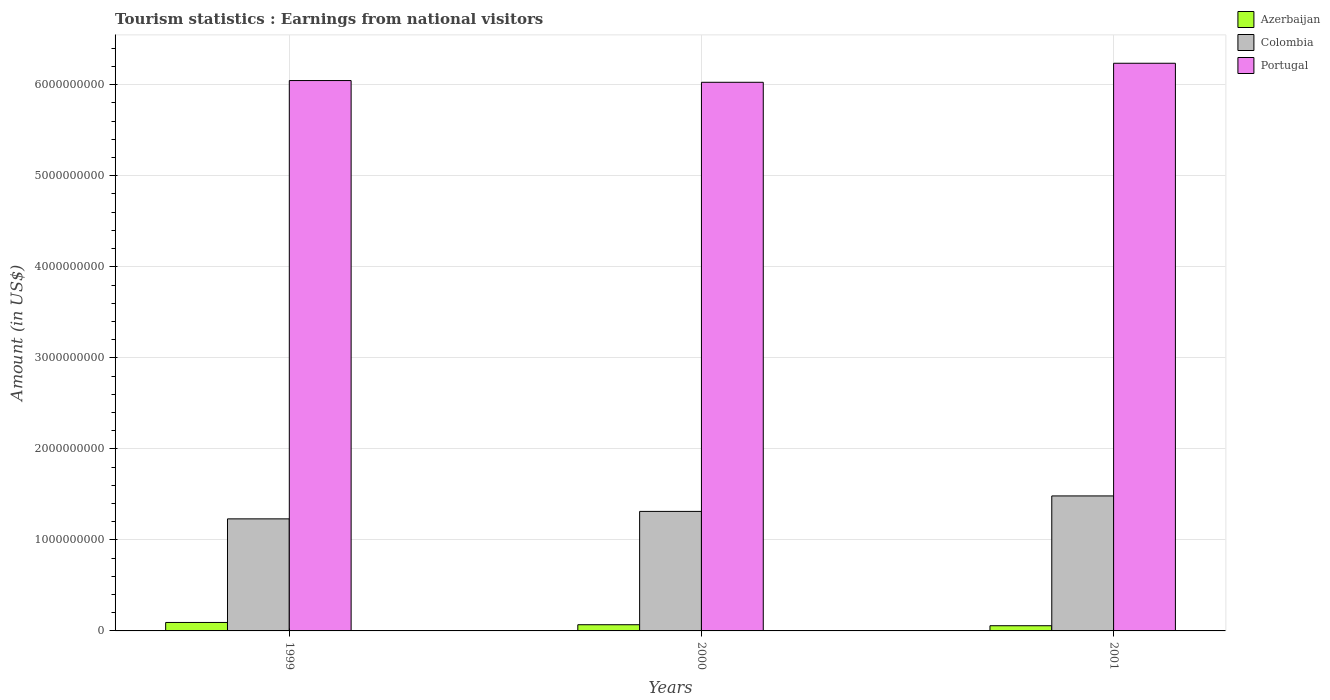How many different coloured bars are there?
Your answer should be compact. 3. How many groups of bars are there?
Ensure brevity in your answer.  3. How many bars are there on the 1st tick from the left?
Ensure brevity in your answer.  3. How many bars are there on the 2nd tick from the right?
Provide a short and direct response. 3. What is the earnings from national visitors in Azerbaijan in 1999?
Your answer should be very brief. 9.30e+07. Across all years, what is the maximum earnings from national visitors in Portugal?
Your answer should be very brief. 6.24e+09. Across all years, what is the minimum earnings from national visitors in Portugal?
Keep it short and to the point. 6.03e+09. In which year was the earnings from national visitors in Azerbaijan minimum?
Your answer should be compact. 2001. What is the total earnings from national visitors in Portugal in the graph?
Your response must be concise. 1.83e+1. What is the difference between the earnings from national visitors in Portugal in 1999 and that in 2001?
Offer a very short reply. -1.90e+08. What is the difference between the earnings from national visitors in Portugal in 2000 and the earnings from national visitors in Azerbaijan in 1999?
Give a very brief answer. 5.93e+09. What is the average earnings from national visitors in Colombia per year?
Give a very brief answer. 1.34e+09. In the year 2000, what is the difference between the earnings from national visitors in Colombia and earnings from national visitors in Portugal?
Offer a terse response. -4.71e+09. What is the ratio of the earnings from national visitors in Colombia in 1999 to that in 2001?
Your answer should be compact. 0.83. Is the earnings from national visitors in Portugal in 1999 less than that in 2000?
Keep it short and to the point. No. What is the difference between the highest and the second highest earnings from national visitors in Colombia?
Provide a short and direct response. 1.70e+08. What is the difference between the highest and the lowest earnings from national visitors in Portugal?
Provide a short and direct response. 2.09e+08. In how many years, is the earnings from national visitors in Portugal greater than the average earnings from national visitors in Portugal taken over all years?
Provide a short and direct response. 1. Is the sum of the earnings from national visitors in Colombia in 1999 and 2001 greater than the maximum earnings from national visitors in Azerbaijan across all years?
Provide a short and direct response. Yes. What does the 1st bar from the left in 2000 represents?
Your answer should be compact. Azerbaijan. What does the 3rd bar from the right in 2001 represents?
Ensure brevity in your answer.  Azerbaijan. Is it the case that in every year, the sum of the earnings from national visitors in Portugal and earnings from national visitors in Colombia is greater than the earnings from national visitors in Azerbaijan?
Offer a very short reply. Yes. How many bars are there?
Make the answer very short. 9. Are all the bars in the graph horizontal?
Your response must be concise. No. How many years are there in the graph?
Your answer should be very brief. 3. What is the difference between two consecutive major ticks on the Y-axis?
Your answer should be very brief. 1.00e+09. Where does the legend appear in the graph?
Provide a succinct answer. Top right. What is the title of the graph?
Ensure brevity in your answer.  Tourism statistics : Earnings from national visitors. What is the label or title of the X-axis?
Make the answer very short. Years. What is the Amount (in US$) of Azerbaijan in 1999?
Provide a short and direct response. 9.30e+07. What is the Amount (in US$) of Colombia in 1999?
Offer a terse response. 1.23e+09. What is the Amount (in US$) of Portugal in 1999?
Ensure brevity in your answer.  6.05e+09. What is the Amount (in US$) in Azerbaijan in 2000?
Offer a terse response. 6.80e+07. What is the Amount (in US$) in Colombia in 2000?
Offer a very short reply. 1.31e+09. What is the Amount (in US$) in Portugal in 2000?
Provide a short and direct response. 6.03e+09. What is the Amount (in US$) of Azerbaijan in 2001?
Keep it short and to the point. 5.70e+07. What is the Amount (in US$) of Colombia in 2001?
Ensure brevity in your answer.  1.48e+09. What is the Amount (in US$) of Portugal in 2001?
Keep it short and to the point. 6.24e+09. Across all years, what is the maximum Amount (in US$) of Azerbaijan?
Offer a very short reply. 9.30e+07. Across all years, what is the maximum Amount (in US$) of Colombia?
Offer a terse response. 1.48e+09. Across all years, what is the maximum Amount (in US$) of Portugal?
Offer a terse response. 6.24e+09. Across all years, what is the minimum Amount (in US$) of Azerbaijan?
Make the answer very short. 5.70e+07. Across all years, what is the minimum Amount (in US$) in Colombia?
Your answer should be compact. 1.23e+09. Across all years, what is the minimum Amount (in US$) in Portugal?
Provide a succinct answer. 6.03e+09. What is the total Amount (in US$) in Azerbaijan in the graph?
Your answer should be compact. 2.18e+08. What is the total Amount (in US$) of Colombia in the graph?
Keep it short and to the point. 4.03e+09. What is the total Amount (in US$) of Portugal in the graph?
Make the answer very short. 1.83e+1. What is the difference between the Amount (in US$) of Azerbaijan in 1999 and that in 2000?
Provide a succinct answer. 2.50e+07. What is the difference between the Amount (in US$) in Colombia in 1999 and that in 2000?
Provide a succinct answer. -8.20e+07. What is the difference between the Amount (in US$) in Portugal in 1999 and that in 2000?
Your answer should be compact. 1.90e+07. What is the difference between the Amount (in US$) of Azerbaijan in 1999 and that in 2001?
Make the answer very short. 3.60e+07. What is the difference between the Amount (in US$) of Colombia in 1999 and that in 2001?
Your answer should be compact. -2.52e+08. What is the difference between the Amount (in US$) of Portugal in 1999 and that in 2001?
Give a very brief answer. -1.90e+08. What is the difference between the Amount (in US$) in Azerbaijan in 2000 and that in 2001?
Your response must be concise. 1.10e+07. What is the difference between the Amount (in US$) of Colombia in 2000 and that in 2001?
Your answer should be compact. -1.70e+08. What is the difference between the Amount (in US$) of Portugal in 2000 and that in 2001?
Your answer should be compact. -2.09e+08. What is the difference between the Amount (in US$) of Azerbaijan in 1999 and the Amount (in US$) of Colombia in 2000?
Ensure brevity in your answer.  -1.22e+09. What is the difference between the Amount (in US$) in Azerbaijan in 1999 and the Amount (in US$) in Portugal in 2000?
Provide a succinct answer. -5.93e+09. What is the difference between the Amount (in US$) in Colombia in 1999 and the Amount (in US$) in Portugal in 2000?
Your answer should be compact. -4.80e+09. What is the difference between the Amount (in US$) in Azerbaijan in 1999 and the Amount (in US$) in Colombia in 2001?
Your response must be concise. -1.39e+09. What is the difference between the Amount (in US$) in Azerbaijan in 1999 and the Amount (in US$) in Portugal in 2001?
Your answer should be compact. -6.14e+09. What is the difference between the Amount (in US$) of Colombia in 1999 and the Amount (in US$) of Portugal in 2001?
Offer a very short reply. -5.00e+09. What is the difference between the Amount (in US$) of Azerbaijan in 2000 and the Amount (in US$) of Colombia in 2001?
Offer a terse response. -1.42e+09. What is the difference between the Amount (in US$) of Azerbaijan in 2000 and the Amount (in US$) of Portugal in 2001?
Give a very brief answer. -6.17e+09. What is the difference between the Amount (in US$) in Colombia in 2000 and the Amount (in US$) in Portugal in 2001?
Ensure brevity in your answer.  -4.92e+09. What is the average Amount (in US$) in Azerbaijan per year?
Offer a terse response. 7.27e+07. What is the average Amount (in US$) in Colombia per year?
Offer a very short reply. 1.34e+09. What is the average Amount (in US$) of Portugal per year?
Make the answer very short. 6.10e+09. In the year 1999, what is the difference between the Amount (in US$) in Azerbaijan and Amount (in US$) in Colombia?
Give a very brief answer. -1.14e+09. In the year 1999, what is the difference between the Amount (in US$) of Azerbaijan and Amount (in US$) of Portugal?
Make the answer very short. -5.95e+09. In the year 1999, what is the difference between the Amount (in US$) of Colombia and Amount (in US$) of Portugal?
Provide a succinct answer. -4.82e+09. In the year 2000, what is the difference between the Amount (in US$) in Azerbaijan and Amount (in US$) in Colombia?
Your answer should be very brief. -1.24e+09. In the year 2000, what is the difference between the Amount (in US$) of Azerbaijan and Amount (in US$) of Portugal?
Keep it short and to the point. -5.96e+09. In the year 2000, what is the difference between the Amount (in US$) in Colombia and Amount (in US$) in Portugal?
Your answer should be compact. -4.71e+09. In the year 2001, what is the difference between the Amount (in US$) in Azerbaijan and Amount (in US$) in Colombia?
Keep it short and to the point. -1.43e+09. In the year 2001, what is the difference between the Amount (in US$) in Azerbaijan and Amount (in US$) in Portugal?
Your answer should be very brief. -6.18e+09. In the year 2001, what is the difference between the Amount (in US$) in Colombia and Amount (in US$) in Portugal?
Keep it short and to the point. -4.75e+09. What is the ratio of the Amount (in US$) of Azerbaijan in 1999 to that in 2000?
Make the answer very short. 1.37. What is the ratio of the Amount (in US$) of Colombia in 1999 to that in 2000?
Make the answer very short. 0.94. What is the ratio of the Amount (in US$) of Portugal in 1999 to that in 2000?
Make the answer very short. 1. What is the ratio of the Amount (in US$) in Azerbaijan in 1999 to that in 2001?
Ensure brevity in your answer.  1.63. What is the ratio of the Amount (in US$) in Colombia in 1999 to that in 2001?
Give a very brief answer. 0.83. What is the ratio of the Amount (in US$) of Portugal in 1999 to that in 2001?
Ensure brevity in your answer.  0.97. What is the ratio of the Amount (in US$) of Azerbaijan in 2000 to that in 2001?
Your answer should be very brief. 1.19. What is the ratio of the Amount (in US$) of Colombia in 2000 to that in 2001?
Your answer should be compact. 0.89. What is the ratio of the Amount (in US$) of Portugal in 2000 to that in 2001?
Your answer should be very brief. 0.97. What is the difference between the highest and the second highest Amount (in US$) in Azerbaijan?
Your answer should be very brief. 2.50e+07. What is the difference between the highest and the second highest Amount (in US$) of Colombia?
Provide a succinct answer. 1.70e+08. What is the difference between the highest and the second highest Amount (in US$) in Portugal?
Offer a terse response. 1.90e+08. What is the difference between the highest and the lowest Amount (in US$) of Azerbaijan?
Your response must be concise. 3.60e+07. What is the difference between the highest and the lowest Amount (in US$) in Colombia?
Provide a short and direct response. 2.52e+08. What is the difference between the highest and the lowest Amount (in US$) of Portugal?
Make the answer very short. 2.09e+08. 